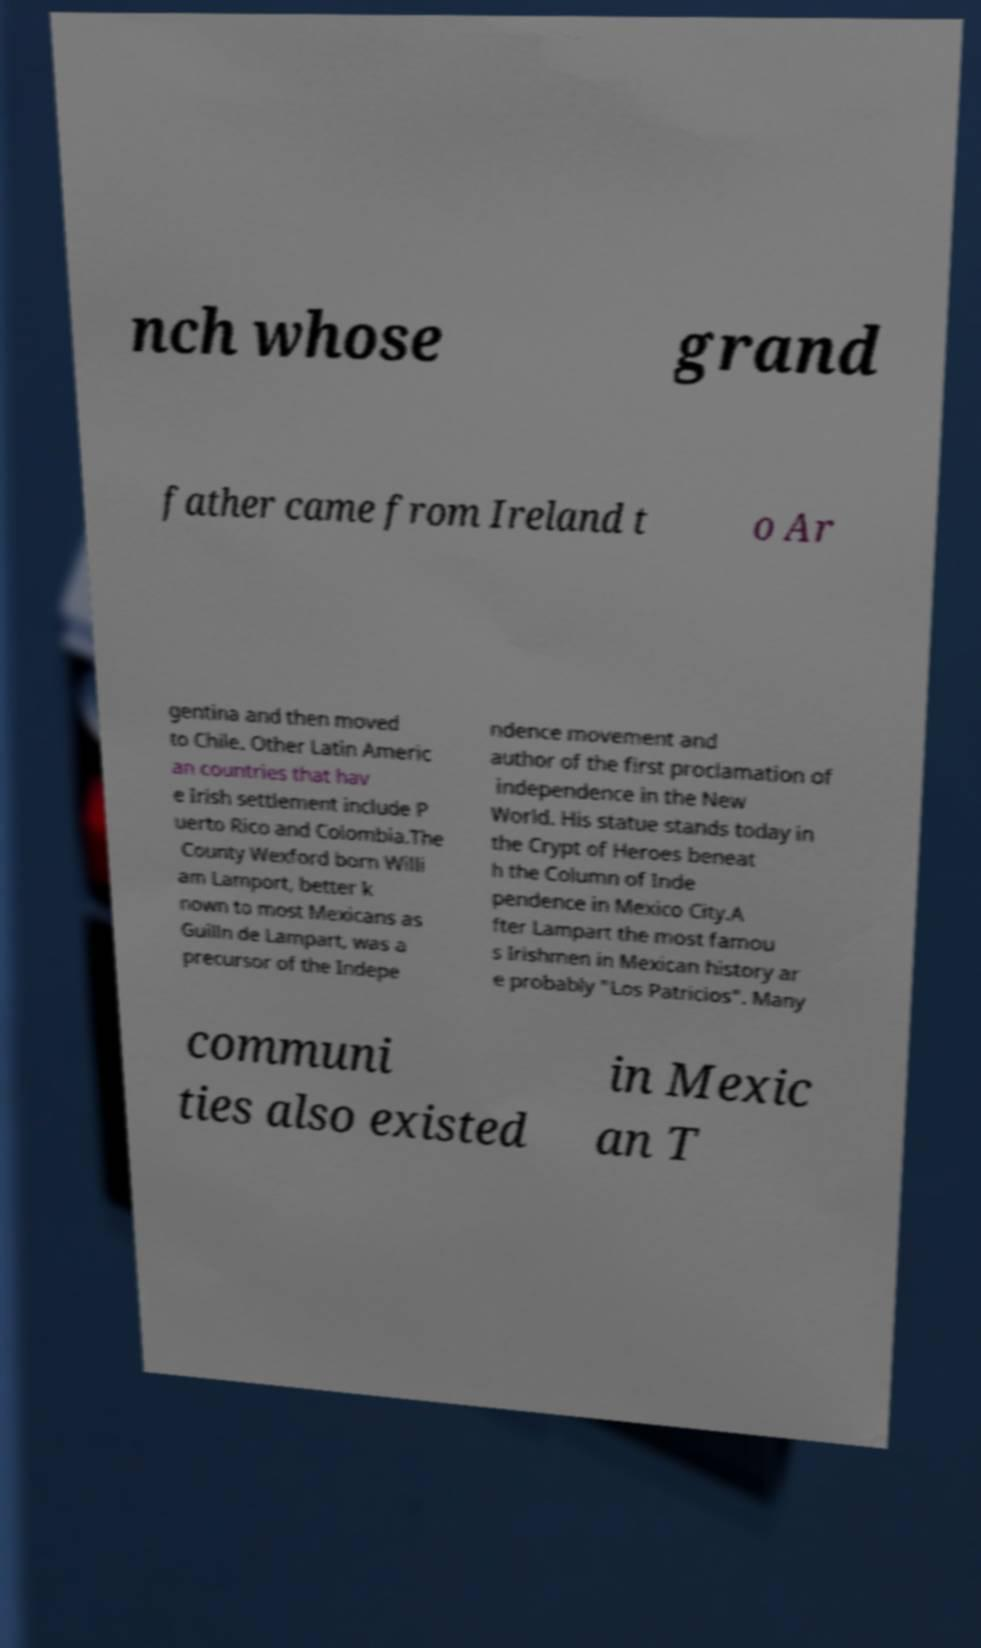For documentation purposes, I need the text within this image transcribed. Could you provide that? nch whose grand father came from Ireland t o Ar gentina and then moved to Chile. Other Latin Americ an countries that hav e Irish settlement include P uerto Rico and Colombia.The County Wexford born Willi am Lamport, better k nown to most Mexicans as Guilln de Lampart, was a precursor of the Indepe ndence movement and author of the first proclamation of independence in the New World. His statue stands today in the Crypt of Heroes beneat h the Column of Inde pendence in Mexico City.A fter Lampart the most famou s Irishmen in Mexican history ar e probably "Los Patricios". Many communi ties also existed in Mexic an T 